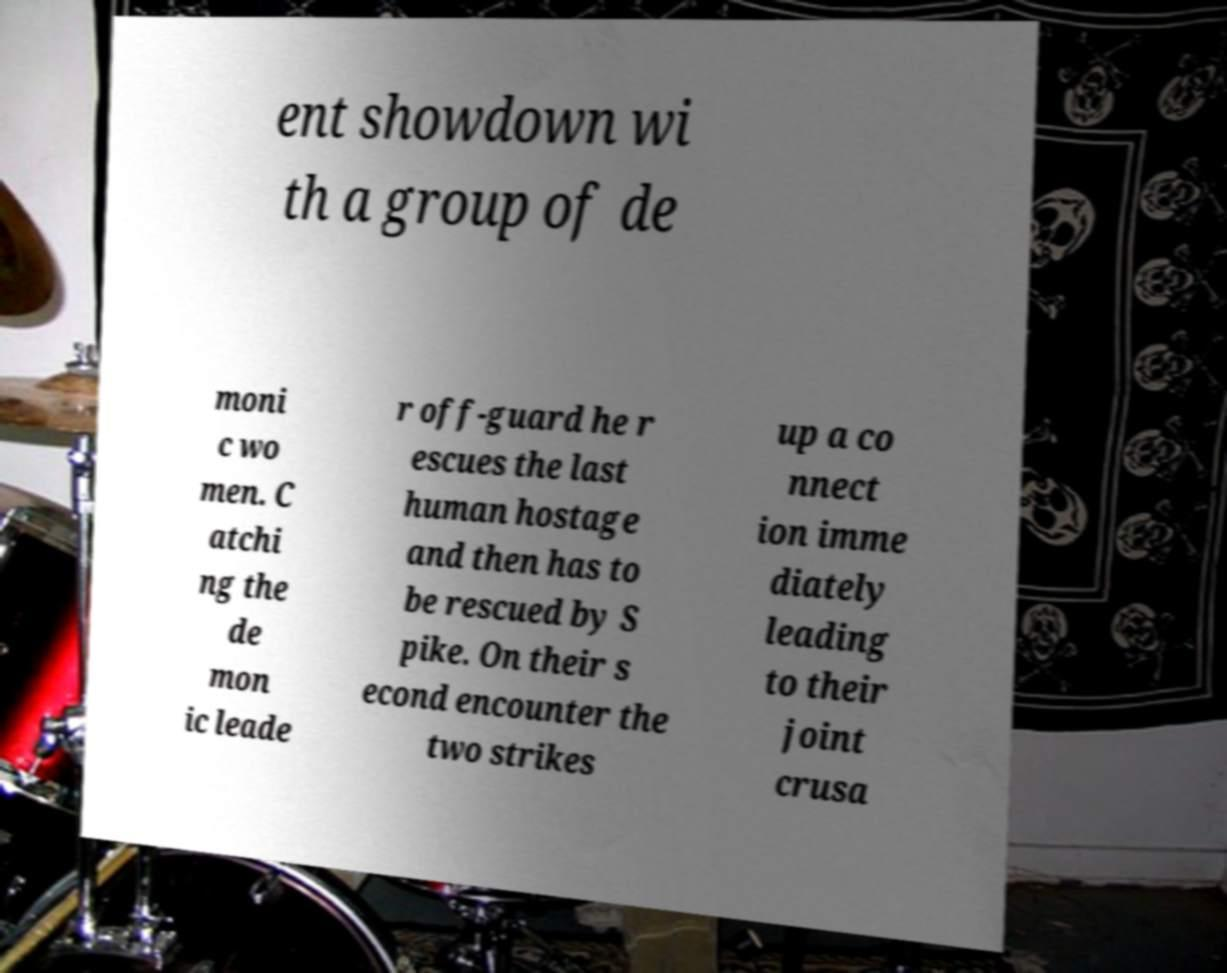Can you read and provide the text displayed in the image?This photo seems to have some interesting text. Can you extract and type it out for me? ent showdown wi th a group of de moni c wo men. C atchi ng the de mon ic leade r off-guard he r escues the last human hostage and then has to be rescued by S pike. On their s econd encounter the two strikes up a co nnect ion imme diately leading to their joint crusa 